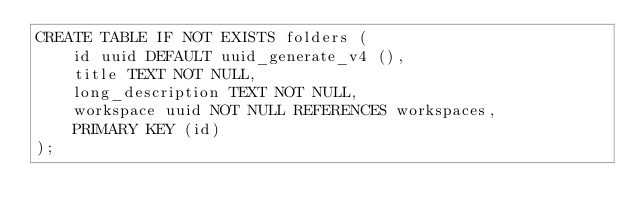Convert code to text. <code><loc_0><loc_0><loc_500><loc_500><_SQL_>CREATE TABLE IF NOT EXISTS folders (
    id uuid DEFAULT uuid_generate_v4 (),
    title TEXT NOT NULL,
    long_description TEXT NOT NULL,
    workspace uuid NOT NULL REFERENCES workspaces,
    PRIMARY KEY (id)
);
</code> 